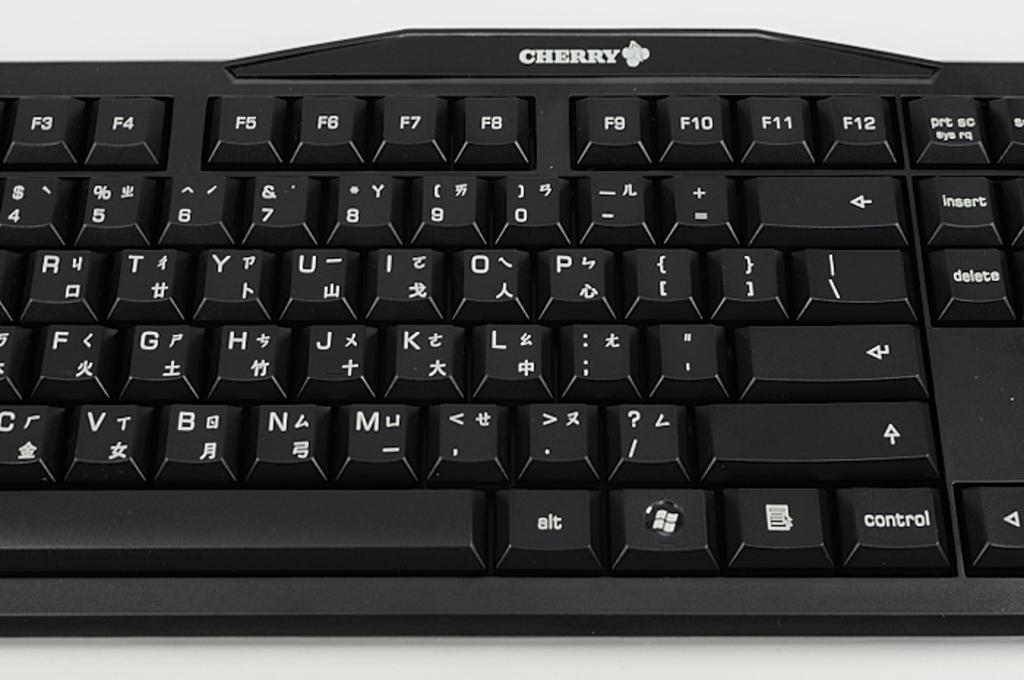What is the main object in the image? There is a keyboard in the image. What color is the background of the image? The background of the image is white. What is the temper of the person using the keyboard in the image? There is no person visible in the image, so it is impossible to determine their temper. 